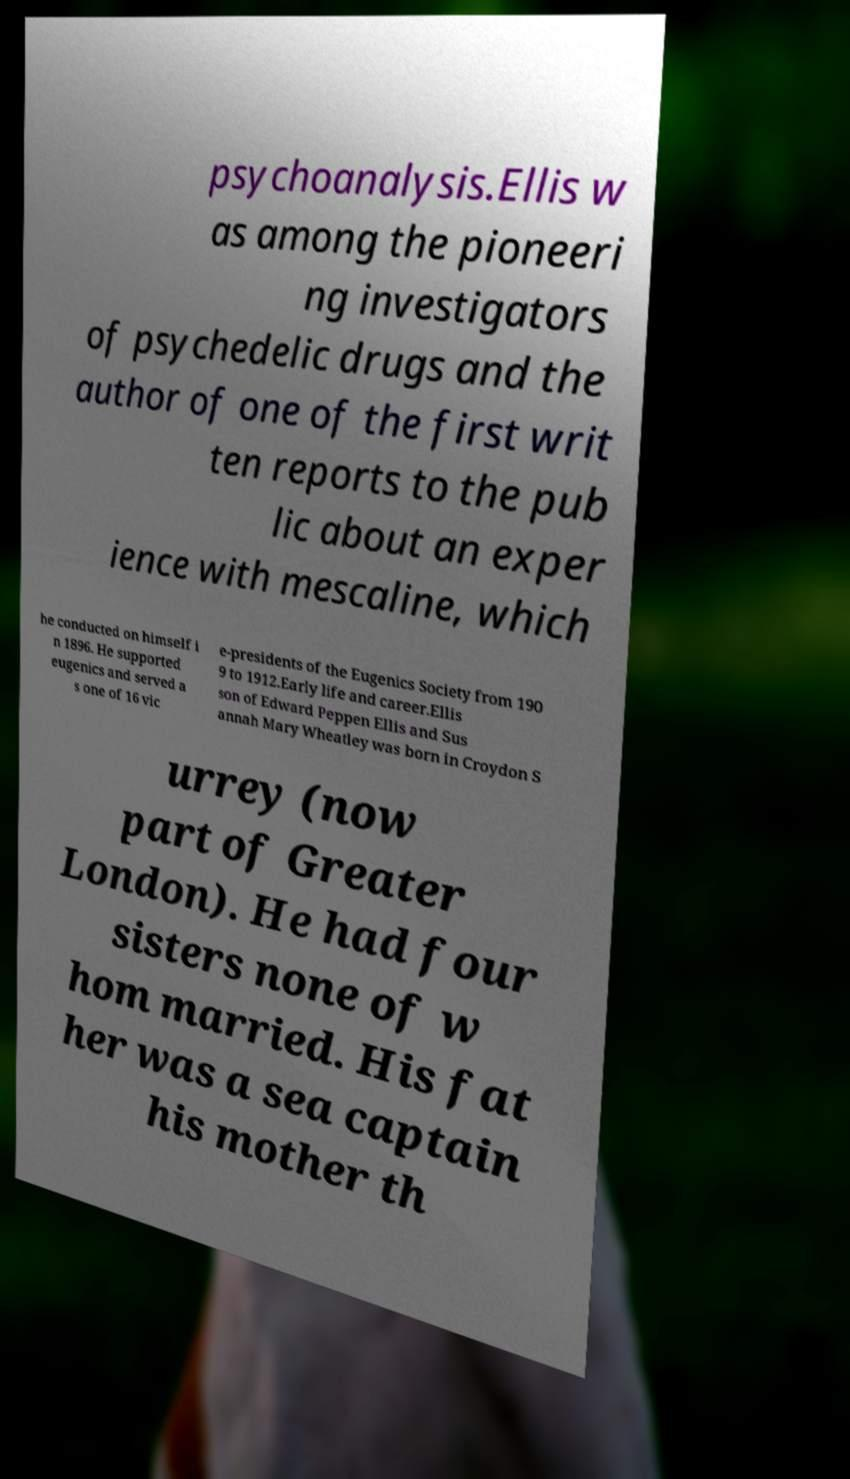Can you read and provide the text displayed in the image?This photo seems to have some interesting text. Can you extract and type it out for me? psychoanalysis.Ellis w as among the pioneeri ng investigators of psychedelic drugs and the author of one of the first writ ten reports to the pub lic about an exper ience with mescaline, which he conducted on himself i n 1896. He supported eugenics and served a s one of 16 vic e-presidents of the Eugenics Society from 190 9 to 1912.Early life and career.Ellis son of Edward Peppen Ellis and Sus annah Mary Wheatley was born in Croydon S urrey (now part of Greater London). He had four sisters none of w hom married. His fat her was a sea captain his mother th 